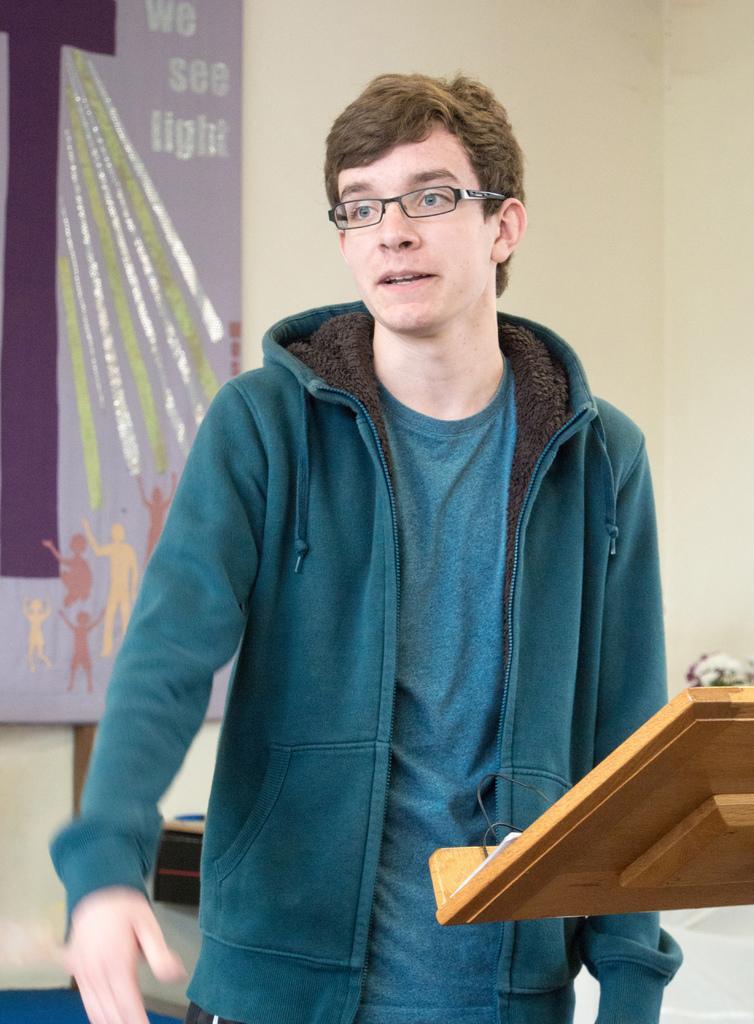Could you give a brief overview of what you see in this image? In this image we can see a person standing and wearing a jacket, in front of him there is an object looks like a podium, on the podium, we can see some objects, in the background we can see the wall and a poster with some text and images. 